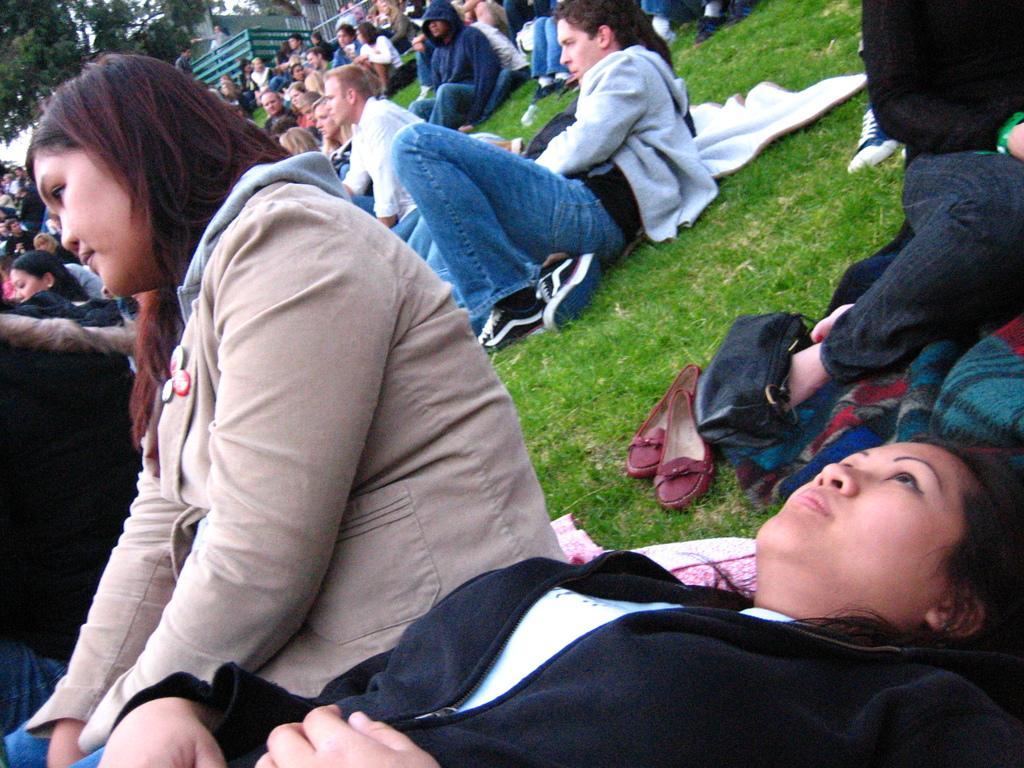Describe this image in one or two sentences. In this image at the bottom a girl is sleeping and looking at someone and at the back there are some people sitting on the ground, and the ground is full of grass. 